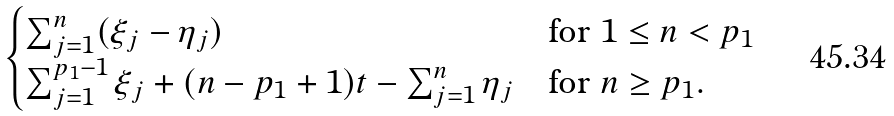Convert formula to latex. <formula><loc_0><loc_0><loc_500><loc_500>\begin{cases} \sum _ { j = 1 } ^ { n } ( \xi _ { j } - \eta _ { j } ) \quad & \text {for } 1 \leq n < p _ { 1 } \\ \sum _ { j = 1 } ^ { p _ { 1 } - 1 } \xi _ { j } + ( n - p _ { 1 } + 1 ) t - \sum _ { j = 1 } ^ { n } \eta _ { j } & \text {for } n \geq p _ { 1 } . \end{cases}</formula> 